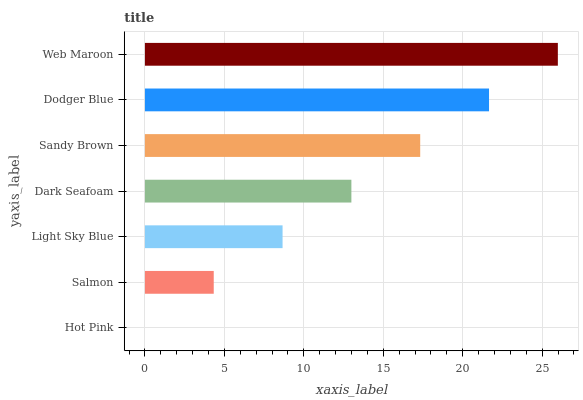Is Hot Pink the minimum?
Answer yes or no. Yes. Is Web Maroon the maximum?
Answer yes or no. Yes. Is Salmon the minimum?
Answer yes or no. No. Is Salmon the maximum?
Answer yes or no. No. Is Salmon greater than Hot Pink?
Answer yes or no. Yes. Is Hot Pink less than Salmon?
Answer yes or no. Yes. Is Hot Pink greater than Salmon?
Answer yes or no. No. Is Salmon less than Hot Pink?
Answer yes or no. No. Is Dark Seafoam the high median?
Answer yes or no. Yes. Is Dark Seafoam the low median?
Answer yes or no. Yes. Is Light Sky Blue the high median?
Answer yes or no. No. Is Dodger Blue the low median?
Answer yes or no. No. 